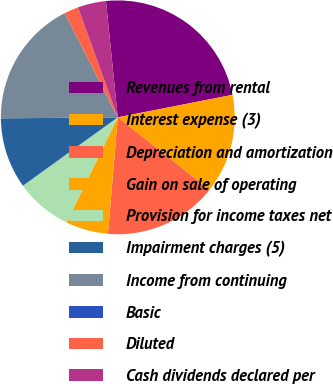Convert chart. <chart><loc_0><loc_0><loc_500><loc_500><pie_chart><fcel>Revenues from rental<fcel>Interest expense (3)<fcel>Depreciation and amortization<fcel>Gain on sale of operating<fcel>Provision for income taxes net<fcel>Impairment charges (5)<fcel>Income from continuing<fcel>Basic<fcel>Diluted<fcel>Cash dividends declared per<nl><fcel>23.53%<fcel>13.73%<fcel>15.69%<fcel>5.88%<fcel>7.84%<fcel>9.8%<fcel>17.65%<fcel>0.0%<fcel>1.96%<fcel>3.92%<nl></chart> 